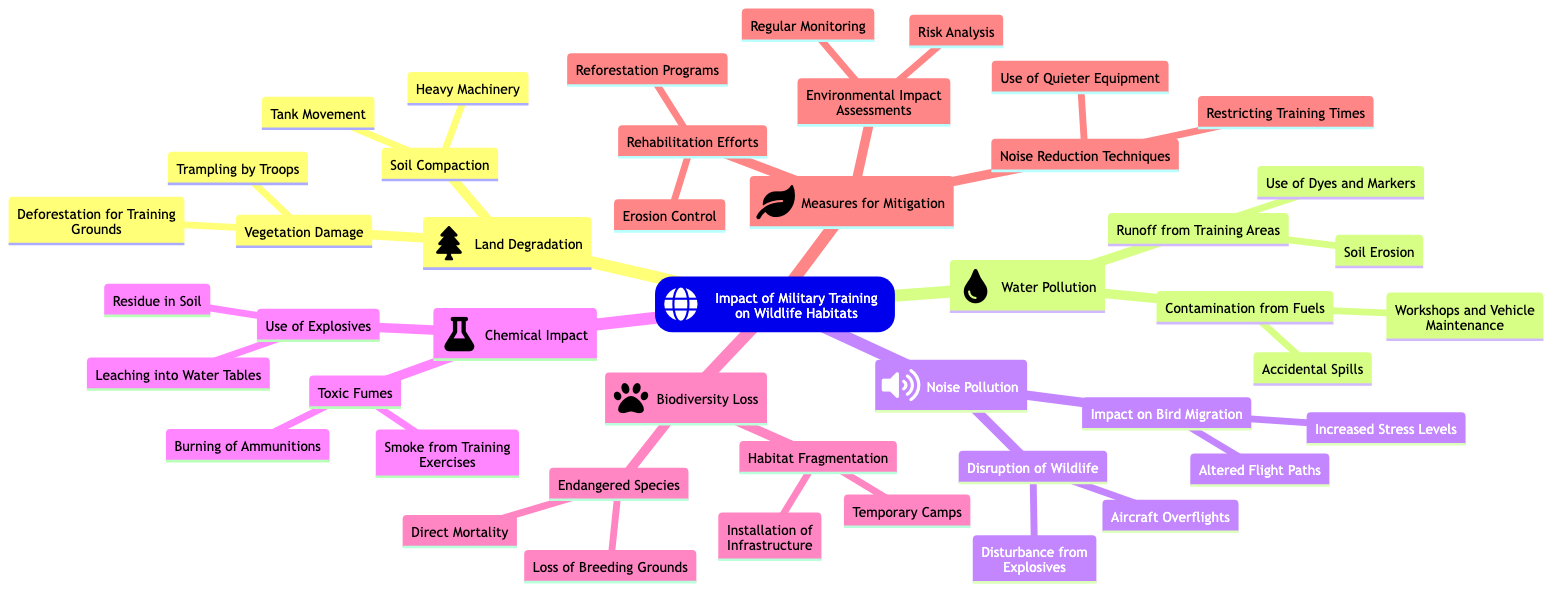What are two causes of soil compaction in military training areas? The diagram lists "Tank Movement" and "Heavy Machinery" as causes under the "Soil Compaction" node in "Land Degradation."
Answer: Tank Movement, Heavy Machinery How many major categories are there in the impact of military training? The diagram features six major categories including "Land Degradation," "Water Pollution," "Noise Pollution," "Chemical Impact," "Biodiversity Loss," and "Measures for Mitigation." Counting these gives a total of six categories.
Answer: 6 What is one example of contamination from fuels? The "Water Pollution" category lists "Workshops and Vehicle Maintenance" under the "Contamination from Fuels" node. This provides an example.
Answer: Workshops and Vehicle Maintenance Which two concepts are associated with "Impact on Bird Migration"? The node "Impact on Bird Migration" includes "Altered Flight Paths" and "Increased Stress Levels." Therefore, these are the associated concepts.
Answer: Altered Flight Paths, Increased Stress Levels What is a mitigation strategy listed in the diagram? The "Measures for Mitigation" category indicates "Environmental Impact Assessments" as a strategy, which comprises "Regular Monitoring" and "Risk Analysis."
Answer: Environmental Impact Assessments How does "Use of Explosives" contribute to chemical impact? The "Use of Explosives" node includes "Residue in Soil" and "Leaching into Water Tables," indicating ways explosives affect the ecosystem.
Answer: Residue in Soil, Leaching into Water Tables How many impacts are listed under "Noise Pollution"? Under "Noise Pollution," there are two main impacts detailed: "Disruption of Wildlife" and "Impact on Bird Migration." Counting these results in two impacts.
Answer: 2 What are the effects of "Toxic Fumes" mentioned in the diagram? "Toxic Fumes" is associated with "Burning of Ammunitions" and "Smoke from Training Exercises," based on the details from the "Chemical Impact" category.
Answer: Burning of Ammunitions, Smoke from Training Exercises 